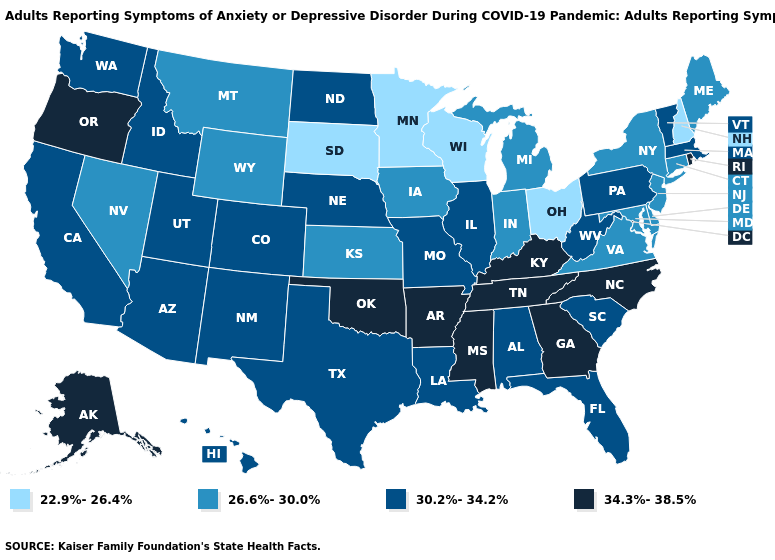What is the lowest value in the USA?
Write a very short answer. 22.9%-26.4%. What is the highest value in states that border Nebraska?
Give a very brief answer. 30.2%-34.2%. What is the value of New Hampshire?
Give a very brief answer. 22.9%-26.4%. Name the states that have a value in the range 30.2%-34.2%?
Answer briefly. Alabama, Arizona, California, Colorado, Florida, Hawaii, Idaho, Illinois, Louisiana, Massachusetts, Missouri, Nebraska, New Mexico, North Dakota, Pennsylvania, South Carolina, Texas, Utah, Vermont, Washington, West Virginia. Name the states that have a value in the range 26.6%-30.0%?
Quick response, please. Connecticut, Delaware, Indiana, Iowa, Kansas, Maine, Maryland, Michigan, Montana, Nevada, New Jersey, New York, Virginia, Wyoming. What is the highest value in states that border North Carolina?
Answer briefly. 34.3%-38.5%. How many symbols are there in the legend?
Quick response, please. 4. Which states hav the highest value in the Northeast?
Write a very short answer. Rhode Island. Does Missouri have the highest value in the MidWest?
Quick response, please. Yes. Which states have the highest value in the USA?
Answer briefly. Alaska, Arkansas, Georgia, Kentucky, Mississippi, North Carolina, Oklahoma, Oregon, Rhode Island, Tennessee. What is the value of North Dakota?
Quick response, please. 30.2%-34.2%. What is the highest value in the MidWest ?
Give a very brief answer. 30.2%-34.2%. Does Hawaii have a higher value than Mississippi?
Short answer required. No. Is the legend a continuous bar?
Write a very short answer. No. Name the states that have a value in the range 34.3%-38.5%?
Be succinct. Alaska, Arkansas, Georgia, Kentucky, Mississippi, North Carolina, Oklahoma, Oregon, Rhode Island, Tennessee. 